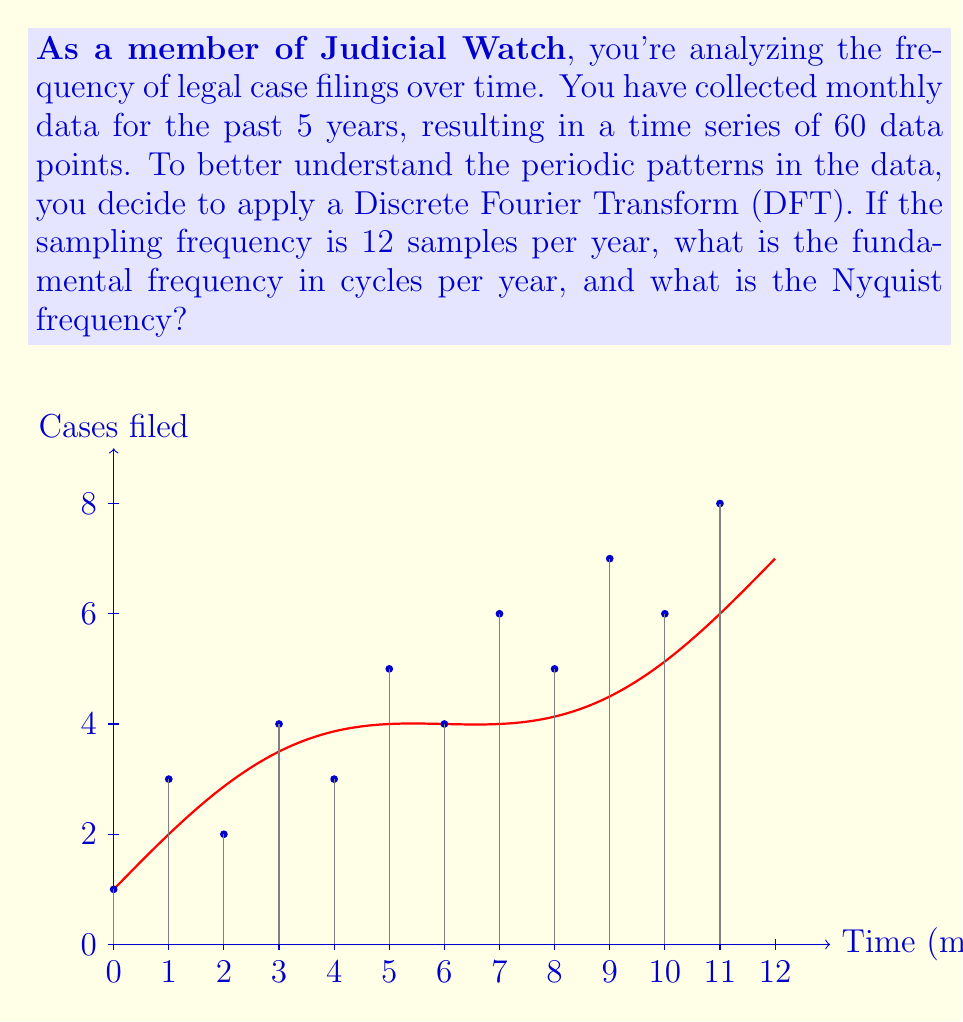Teach me how to tackle this problem. To solve this problem, we need to understand a few key concepts:

1. Sampling frequency: This is the number of samples taken per unit time. In this case, it's 12 samples per year.

2. Fundamental frequency: This is the lowest frequency component in the Fourier transform, corresponding to the full period of the data. It's calculated as:

   $$f_0 = \frac{f_s}{N}$$

   where $f_s$ is the sampling frequency and $N$ is the total number of samples.

3. Nyquist frequency: This is the highest frequency that can be accurately represented in the discrete Fourier transform, equal to half the sampling frequency.

Now, let's solve the problem step-by-step:

1. Calculate the fundamental frequency:
   $f_s = 12$ samples/year
   $N = 60$ samples (5 years * 12 samples/year)
   
   $$f_0 = \frac{f_s}{N} = \frac{12}{60} = 0.2$$ cycles/year

2. Calculate the Nyquist frequency:
   The Nyquist frequency is half the sampling frequency.
   
   $$f_{Nyquist} = \frac{f_s}{2} = \frac{12}{2} = 6$$ cycles/year

Therefore, the fundamental frequency is 0.2 cycles/year, and the Nyquist frequency is 6 cycles/year.
Answer: Fundamental frequency: 0.2 cycles/year; Nyquist frequency: 6 cycles/year 